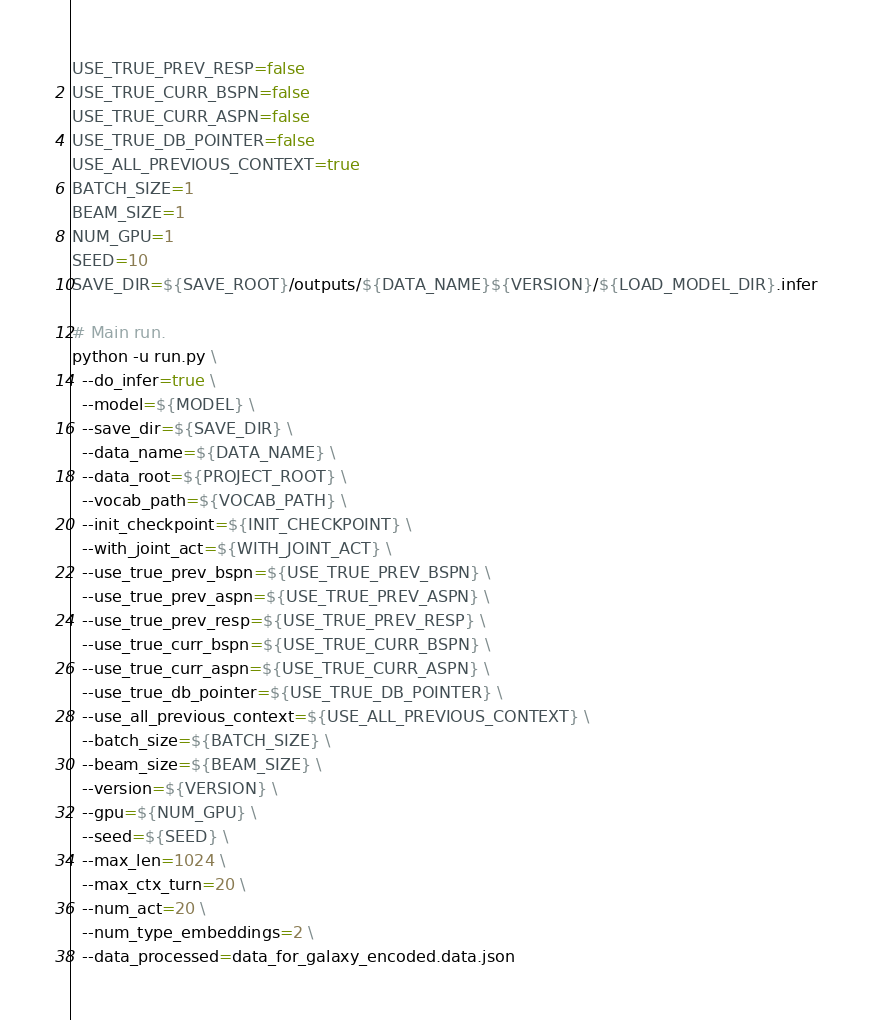Convert code to text. <code><loc_0><loc_0><loc_500><loc_500><_Bash_>USE_TRUE_PREV_RESP=false
USE_TRUE_CURR_BSPN=false
USE_TRUE_CURR_ASPN=false
USE_TRUE_DB_POINTER=false
USE_ALL_PREVIOUS_CONTEXT=true
BATCH_SIZE=1
BEAM_SIZE=1
NUM_GPU=1
SEED=10
SAVE_DIR=${SAVE_ROOT}/outputs/${DATA_NAME}${VERSION}/${LOAD_MODEL_DIR}.infer

# Main run.
python -u run.py \
  --do_infer=true \
  --model=${MODEL} \
  --save_dir=${SAVE_DIR} \
  --data_name=${DATA_NAME} \
  --data_root=${PROJECT_ROOT} \
  --vocab_path=${VOCAB_PATH} \
  --init_checkpoint=${INIT_CHECKPOINT} \
  --with_joint_act=${WITH_JOINT_ACT} \
  --use_true_prev_bspn=${USE_TRUE_PREV_BSPN} \
  --use_true_prev_aspn=${USE_TRUE_PREV_ASPN} \
  --use_true_prev_resp=${USE_TRUE_PREV_RESP} \
  --use_true_curr_bspn=${USE_TRUE_CURR_BSPN} \
  --use_true_curr_aspn=${USE_TRUE_CURR_ASPN} \
  --use_true_db_pointer=${USE_TRUE_DB_POINTER} \
  --use_all_previous_context=${USE_ALL_PREVIOUS_CONTEXT} \
  --batch_size=${BATCH_SIZE} \
  --beam_size=${BEAM_SIZE} \
  --version=${VERSION} \
  --gpu=${NUM_GPU} \
  --seed=${SEED} \
  --max_len=1024 \
  --max_ctx_turn=20 \
  --num_act=20 \
  --num_type_embeddings=2 \
  --data_processed=data_for_galaxy_encoded.data.json
</code> 